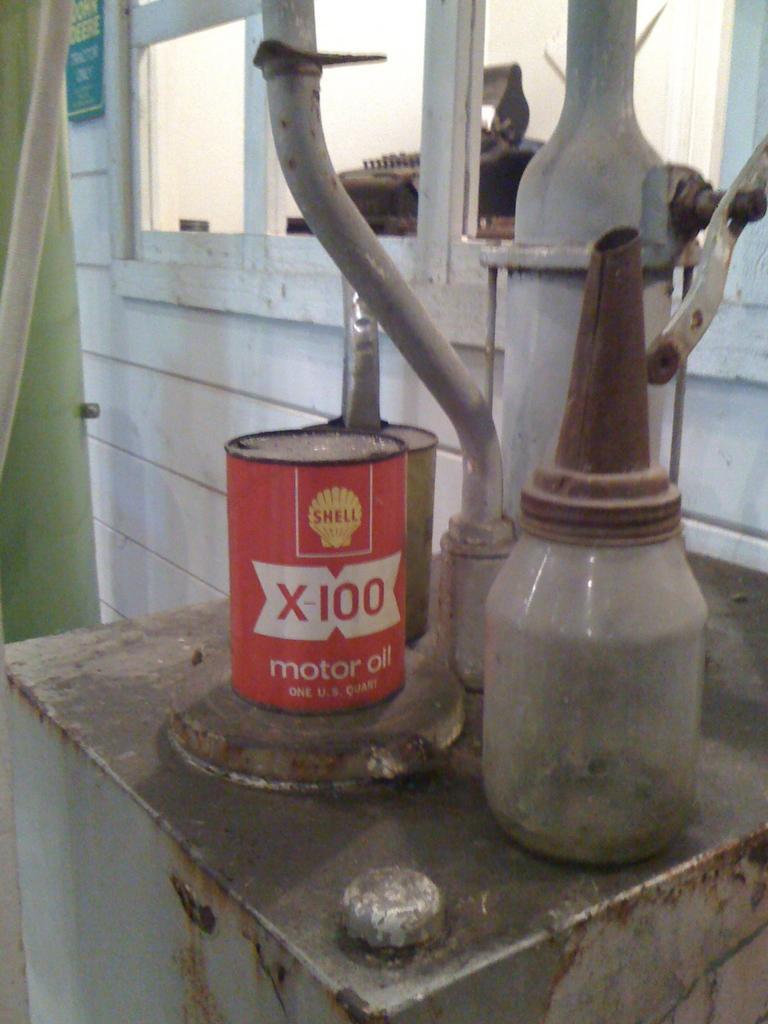In one or two sentences, can you explain what this image depicts? In this image there are some object, in the background there is a wall to that wall there is a window and there is a curtain. 